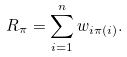Convert formula to latex. <formula><loc_0><loc_0><loc_500><loc_500>R _ { \pi } = \sum _ { i = 1 } ^ { n } w _ { i \pi ( i ) } .</formula> 